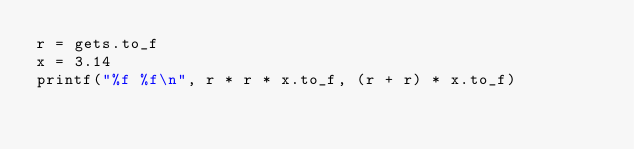<code> <loc_0><loc_0><loc_500><loc_500><_Ruby_>r = gets.to_f
x = 3.14
printf("%f %f\n", r * r * x.to_f, (r + r) * x.to_f)</code> 